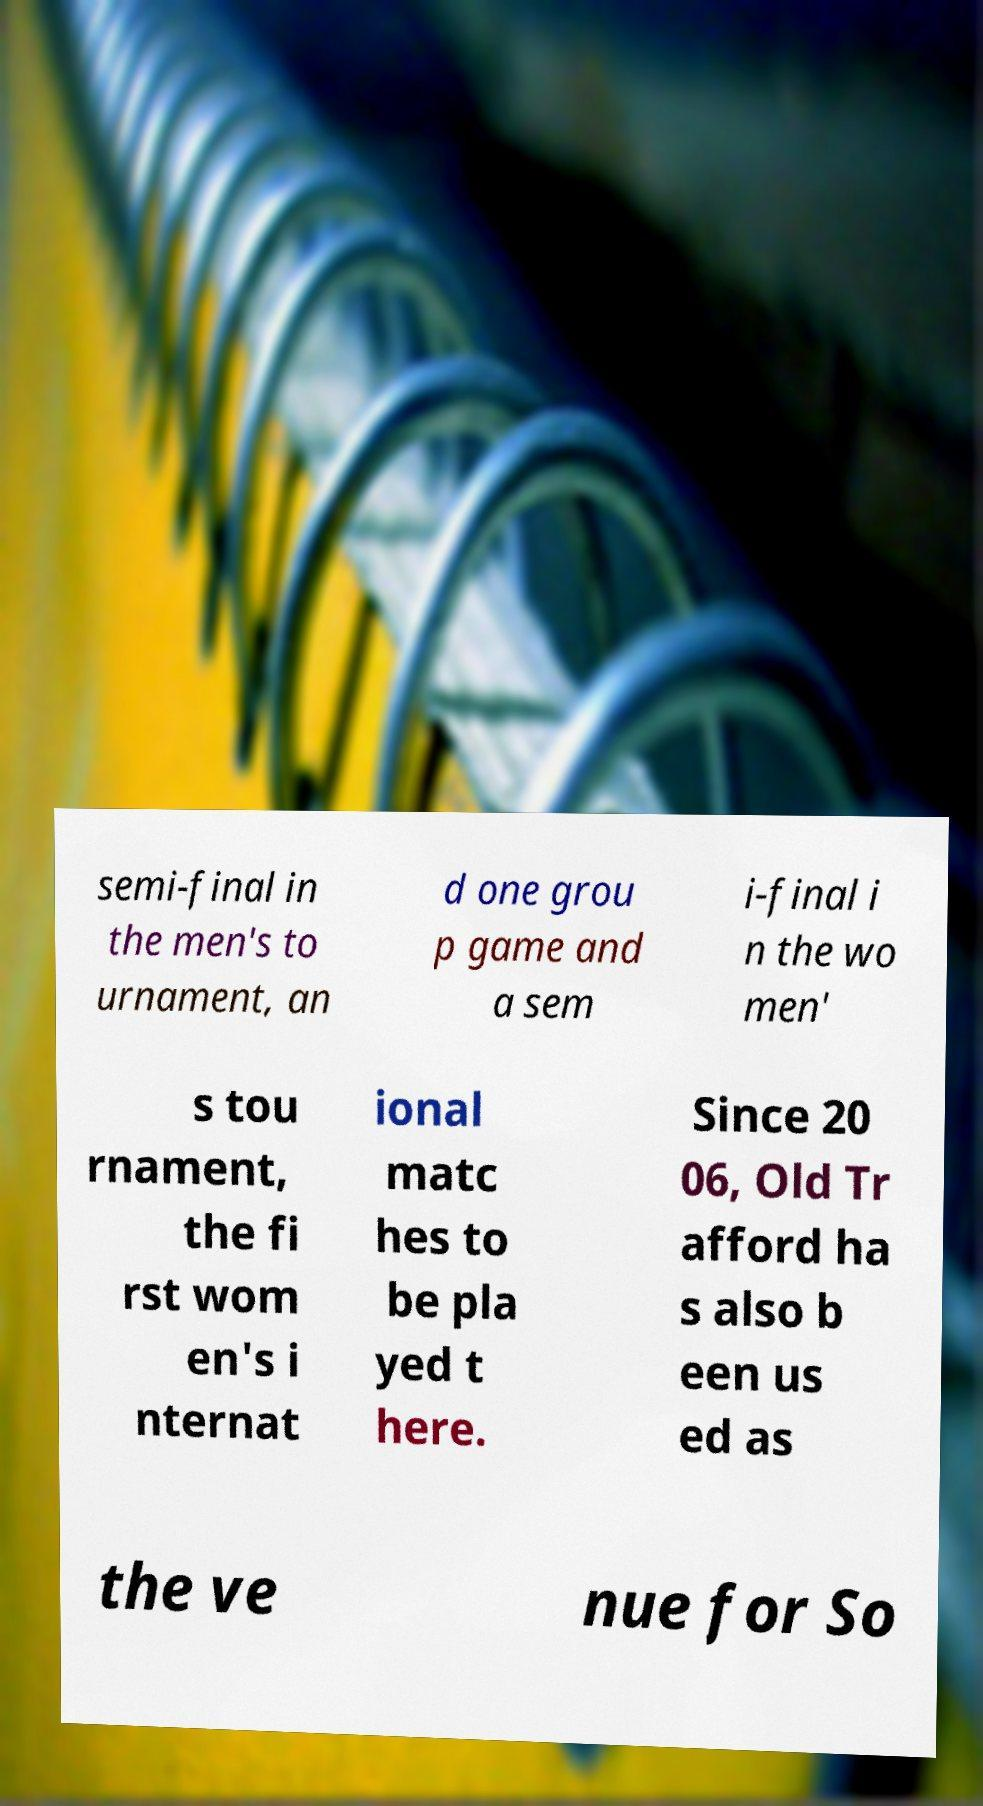Can you accurately transcribe the text from the provided image for me? semi-final in the men's to urnament, an d one grou p game and a sem i-final i n the wo men' s tou rnament, the fi rst wom en's i nternat ional matc hes to be pla yed t here. Since 20 06, Old Tr afford ha s also b een us ed as the ve nue for So 